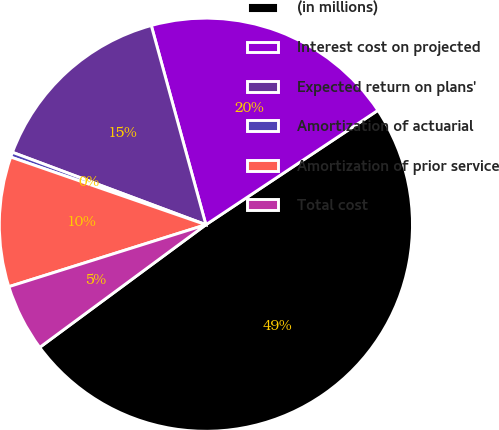Convert chart to OTSL. <chart><loc_0><loc_0><loc_500><loc_500><pie_chart><fcel>(in millions)<fcel>Interest cost on projected<fcel>Expected return on plans'<fcel>Amortization of actuarial<fcel>Amortization of prior service<fcel>Total cost<nl><fcel>49.22%<fcel>19.92%<fcel>15.04%<fcel>0.39%<fcel>10.16%<fcel>5.27%<nl></chart> 